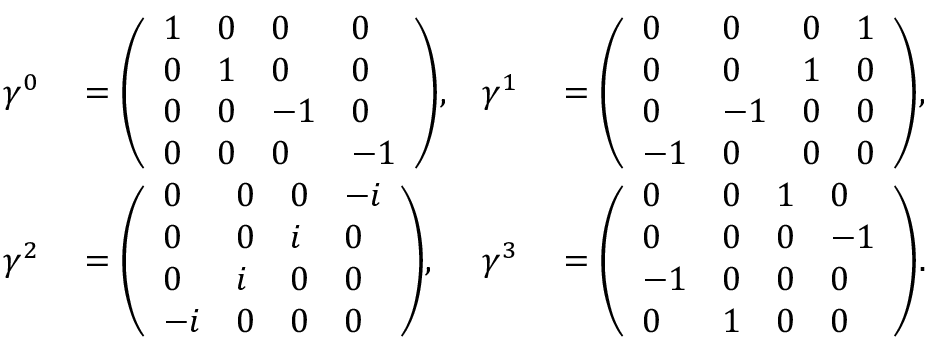<formula> <loc_0><loc_0><loc_500><loc_500>\begin{array} { r l r l } { \gamma ^ { 0 } } & = { \left ( \begin{array} { l l l l } { 1 } & { 0 } & { 0 } & { 0 } \\ { 0 } & { 1 } & { 0 } & { 0 } \\ { 0 } & { 0 } & { - 1 } & { 0 } \\ { 0 } & { 0 } & { 0 } & { - 1 } \end{array} \right ) } , } & { \gamma ^ { 1 } } & = { \left ( \begin{array} { l l l l } { 0 } & { 0 } & { 0 } & { 1 } \\ { 0 } & { 0 } & { 1 } & { 0 } \\ { 0 } & { - 1 } & { 0 } & { 0 } \\ { - 1 } & { 0 } & { 0 } & { 0 } \end{array} \right ) } , } \\ { \gamma ^ { 2 } } & = { \left ( \begin{array} { l l l l } { 0 } & { 0 } & { 0 } & { - i } \\ { 0 } & { 0 } & { i } & { 0 } \\ { 0 } & { i } & { 0 } & { 0 } \\ { - i } & { 0 } & { 0 } & { 0 } \end{array} \right ) } , } & { \gamma ^ { 3 } } & = { \left ( \begin{array} { l l l l } { 0 } & { 0 } & { 1 } & { 0 } \\ { 0 } & { 0 } & { 0 } & { - 1 } \\ { - 1 } & { 0 } & { 0 } & { 0 } \\ { 0 } & { 1 } & { 0 } & { 0 } \end{array} \right ) } . } \end{array}</formula> 